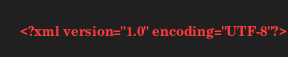<code> <loc_0><loc_0><loc_500><loc_500><_XML_><?xml version="1.0" encoding="UTF-8"?></code> 